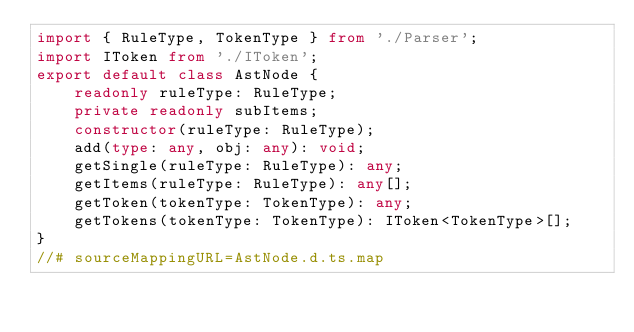Convert code to text. <code><loc_0><loc_0><loc_500><loc_500><_TypeScript_>import { RuleType, TokenType } from './Parser';
import IToken from './IToken';
export default class AstNode {
    readonly ruleType: RuleType;
    private readonly subItems;
    constructor(ruleType: RuleType);
    add(type: any, obj: any): void;
    getSingle(ruleType: RuleType): any;
    getItems(ruleType: RuleType): any[];
    getToken(tokenType: TokenType): any;
    getTokens(tokenType: TokenType): IToken<TokenType>[];
}
//# sourceMappingURL=AstNode.d.ts.map</code> 